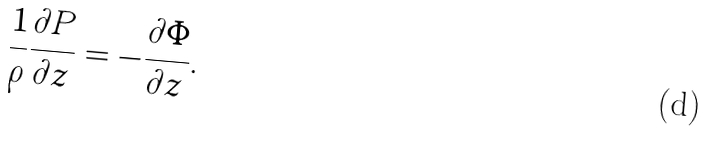<formula> <loc_0><loc_0><loc_500><loc_500>\frac { 1 } { \rho } \frac { \partial P } { \partial z } = - \frac { \partial \Phi } { \partial z } .</formula> 